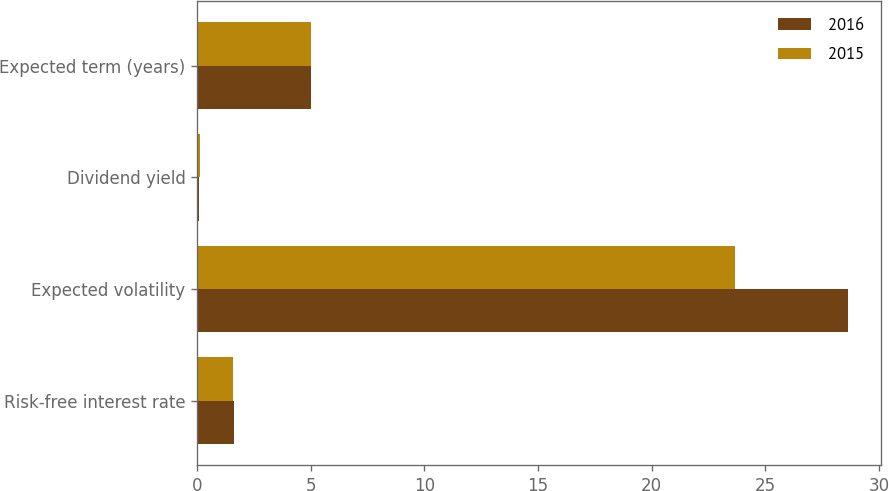Convert chart to OTSL. <chart><loc_0><loc_0><loc_500><loc_500><stacked_bar_chart><ecel><fcel>Risk-free interest rate<fcel>Expected volatility<fcel>Dividend yield<fcel>Expected term (years)<nl><fcel>2016<fcel>1.62<fcel>28.65<fcel>0.1<fcel>5<nl><fcel>2015<fcel>1.57<fcel>23.65<fcel>0.13<fcel>5<nl></chart> 